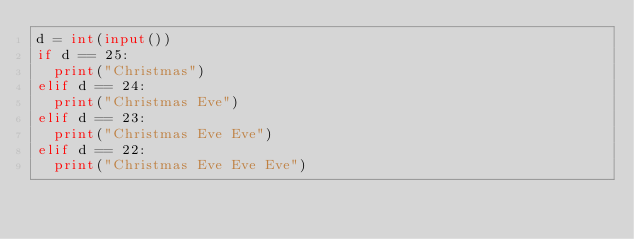<code> <loc_0><loc_0><loc_500><loc_500><_Python_>d = int(input())
if d == 25:
  print("Christmas")
elif d == 24:
  print("Christmas Eve")
elif d == 23:
  print("Christmas Eve Eve")
elif d == 22:
  print("Christmas Eve Eve Eve")
</code> 